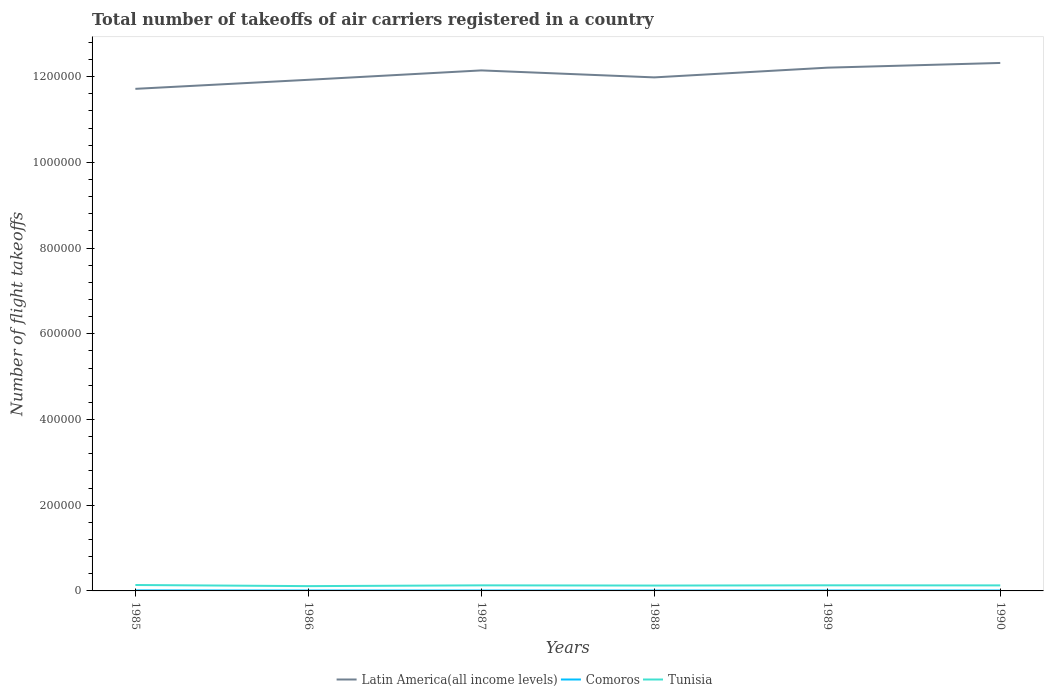How many different coloured lines are there?
Ensure brevity in your answer.  3. Does the line corresponding to Comoros intersect with the line corresponding to Tunisia?
Offer a terse response. No. Across all years, what is the maximum total number of flight takeoffs in Latin America(all income levels)?
Ensure brevity in your answer.  1.17e+06. In which year was the total number of flight takeoffs in Latin America(all income levels) maximum?
Make the answer very short. 1985. What is the difference between the highest and the lowest total number of flight takeoffs in Latin America(all income levels)?
Your answer should be compact. 3. Is the total number of flight takeoffs in Comoros strictly greater than the total number of flight takeoffs in Tunisia over the years?
Provide a succinct answer. Yes. How many lines are there?
Your response must be concise. 3. How many years are there in the graph?
Make the answer very short. 6. What is the difference between two consecutive major ticks on the Y-axis?
Offer a very short reply. 2.00e+05. Are the values on the major ticks of Y-axis written in scientific E-notation?
Give a very brief answer. No. Does the graph contain any zero values?
Offer a very short reply. No. Does the graph contain grids?
Make the answer very short. No. How many legend labels are there?
Your answer should be very brief. 3. How are the legend labels stacked?
Your answer should be very brief. Horizontal. What is the title of the graph?
Your answer should be very brief. Total number of takeoffs of air carriers registered in a country. What is the label or title of the X-axis?
Your response must be concise. Years. What is the label or title of the Y-axis?
Your answer should be compact. Number of flight takeoffs. What is the Number of flight takeoffs in Latin America(all income levels) in 1985?
Your response must be concise. 1.17e+06. What is the Number of flight takeoffs in Comoros in 1985?
Offer a very short reply. 1200. What is the Number of flight takeoffs of Tunisia in 1985?
Make the answer very short. 1.38e+04. What is the Number of flight takeoffs in Latin America(all income levels) in 1986?
Ensure brevity in your answer.  1.19e+06. What is the Number of flight takeoffs in Tunisia in 1986?
Ensure brevity in your answer.  1.12e+04. What is the Number of flight takeoffs of Latin America(all income levels) in 1987?
Give a very brief answer. 1.21e+06. What is the Number of flight takeoffs of Tunisia in 1987?
Make the answer very short. 1.30e+04. What is the Number of flight takeoffs in Latin America(all income levels) in 1988?
Ensure brevity in your answer.  1.20e+06. What is the Number of flight takeoffs in Tunisia in 1988?
Ensure brevity in your answer.  1.25e+04. What is the Number of flight takeoffs of Latin America(all income levels) in 1989?
Give a very brief answer. 1.22e+06. What is the Number of flight takeoffs of Tunisia in 1989?
Provide a short and direct response. 1.31e+04. What is the Number of flight takeoffs in Latin America(all income levels) in 1990?
Provide a short and direct response. 1.23e+06. What is the Number of flight takeoffs in Tunisia in 1990?
Provide a succinct answer. 1.29e+04. Across all years, what is the maximum Number of flight takeoffs in Latin America(all income levels)?
Offer a terse response. 1.23e+06. Across all years, what is the maximum Number of flight takeoffs in Comoros?
Make the answer very short. 1200. Across all years, what is the maximum Number of flight takeoffs of Tunisia?
Offer a terse response. 1.38e+04. Across all years, what is the minimum Number of flight takeoffs in Latin America(all income levels)?
Offer a terse response. 1.17e+06. Across all years, what is the minimum Number of flight takeoffs in Comoros?
Ensure brevity in your answer.  1000. Across all years, what is the minimum Number of flight takeoffs in Tunisia?
Keep it short and to the point. 1.12e+04. What is the total Number of flight takeoffs in Latin America(all income levels) in the graph?
Provide a short and direct response. 7.23e+06. What is the total Number of flight takeoffs in Comoros in the graph?
Provide a short and direct response. 6200. What is the total Number of flight takeoffs of Tunisia in the graph?
Provide a short and direct response. 7.65e+04. What is the difference between the Number of flight takeoffs of Latin America(all income levels) in 1985 and that in 1986?
Keep it short and to the point. -2.11e+04. What is the difference between the Number of flight takeoffs of Comoros in 1985 and that in 1986?
Provide a short and direct response. 200. What is the difference between the Number of flight takeoffs of Tunisia in 1985 and that in 1986?
Your answer should be compact. 2600. What is the difference between the Number of flight takeoffs of Latin America(all income levels) in 1985 and that in 1987?
Ensure brevity in your answer.  -4.30e+04. What is the difference between the Number of flight takeoffs of Tunisia in 1985 and that in 1987?
Your answer should be very brief. 800. What is the difference between the Number of flight takeoffs in Latin America(all income levels) in 1985 and that in 1988?
Your answer should be compact. -2.67e+04. What is the difference between the Number of flight takeoffs of Tunisia in 1985 and that in 1988?
Provide a succinct answer. 1300. What is the difference between the Number of flight takeoffs of Latin America(all income levels) in 1985 and that in 1989?
Provide a short and direct response. -4.94e+04. What is the difference between the Number of flight takeoffs of Comoros in 1985 and that in 1989?
Your response must be concise. 200. What is the difference between the Number of flight takeoffs in Tunisia in 1985 and that in 1989?
Provide a succinct answer. 700. What is the difference between the Number of flight takeoffs of Latin America(all income levels) in 1985 and that in 1990?
Your response must be concise. -6.04e+04. What is the difference between the Number of flight takeoffs in Tunisia in 1985 and that in 1990?
Give a very brief answer. 900. What is the difference between the Number of flight takeoffs in Latin America(all income levels) in 1986 and that in 1987?
Offer a very short reply. -2.19e+04. What is the difference between the Number of flight takeoffs of Comoros in 1986 and that in 1987?
Offer a very short reply. 0. What is the difference between the Number of flight takeoffs in Tunisia in 1986 and that in 1987?
Provide a short and direct response. -1800. What is the difference between the Number of flight takeoffs of Latin America(all income levels) in 1986 and that in 1988?
Ensure brevity in your answer.  -5600. What is the difference between the Number of flight takeoffs of Tunisia in 1986 and that in 1988?
Make the answer very short. -1300. What is the difference between the Number of flight takeoffs in Latin America(all income levels) in 1986 and that in 1989?
Provide a succinct answer. -2.83e+04. What is the difference between the Number of flight takeoffs of Comoros in 1986 and that in 1989?
Keep it short and to the point. 0. What is the difference between the Number of flight takeoffs in Tunisia in 1986 and that in 1989?
Offer a terse response. -1900. What is the difference between the Number of flight takeoffs in Latin America(all income levels) in 1986 and that in 1990?
Provide a short and direct response. -3.93e+04. What is the difference between the Number of flight takeoffs in Tunisia in 1986 and that in 1990?
Give a very brief answer. -1700. What is the difference between the Number of flight takeoffs in Latin America(all income levels) in 1987 and that in 1988?
Provide a short and direct response. 1.63e+04. What is the difference between the Number of flight takeoffs of Comoros in 1987 and that in 1988?
Your response must be concise. 0. What is the difference between the Number of flight takeoffs in Tunisia in 1987 and that in 1988?
Ensure brevity in your answer.  500. What is the difference between the Number of flight takeoffs of Latin America(all income levels) in 1987 and that in 1989?
Your answer should be compact. -6400. What is the difference between the Number of flight takeoffs of Tunisia in 1987 and that in 1989?
Give a very brief answer. -100. What is the difference between the Number of flight takeoffs in Latin America(all income levels) in 1987 and that in 1990?
Provide a short and direct response. -1.74e+04. What is the difference between the Number of flight takeoffs of Comoros in 1987 and that in 1990?
Give a very brief answer. 0. What is the difference between the Number of flight takeoffs in Tunisia in 1987 and that in 1990?
Offer a very short reply. 100. What is the difference between the Number of flight takeoffs of Latin America(all income levels) in 1988 and that in 1989?
Offer a terse response. -2.27e+04. What is the difference between the Number of flight takeoffs of Tunisia in 1988 and that in 1989?
Make the answer very short. -600. What is the difference between the Number of flight takeoffs of Latin America(all income levels) in 1988 and that in 1990?
Your answer should be very brief. -3.37e+04. What is the difference between the Number of flight takeoffs in Tunisia in 1988 and that in 1990?
Offer a terse response. -400. What is the difference between the Number of flight takeoffs in Latin America(all income levels) in 1989 and that in 1990?
Offer a very short reply. -1.10e+04. What is the difference between the Number of flight takeoffs of Comoros in 1989 and that in 1990?
Make the answer very short. 0. What is the difference between the Number of flight takeoffs in Tunisia in 1989 and that in 1990?
Ensure brevity in your answer.  200. What is the difference between the Number of flight takeoffs in Latin America(all income levels) in 1985 and the Number of flight takeoffs in Comoros in 1986?
Provide a succinct answer. 1.17e+06. What is the difference between the Number of flight takeoffs of Latin America(all income levels) in 1985 and the Number of flight takeoffs of Tunisia in 1986?
Keep it short and to the point. 1.16e+06. What is the difference between the Number of flight takeoffs of Latin America(all income levels) in 1985 and the Number of flight takeoffs of Comoros in 1987?
Ensure brevity in your answer.  1.17e+06. What is the difference between the Number of flight takeoffs of Latin America(all income levels) in 1985 and the Number of flight takeoffs of Tunisia in 1987?
Your answer should be very brief. 1.16e+06. What is the difference between the Number of flight takeoffs of Comoros in 1985 and the Number of flight takeoffs of Tunisia in 1987?
Your answer should be very brief. -1.18e+04. What is the difference between the Number of flight takeoffs in Latin America(all income levels) in 1985 and the Number of flight takeoffs in Comoros in 1988?
Your response must be concise. 1.17e+06. What is the difference between the Number of flight takeoffs of Latin America(all income levels) in 1985 and the Number of flight takeoffs of Tunisia in 1988?
Provide a short and direct response. 1.16e+06. What is the difference between the Number of flight takeoffs in Comoros in 1985 and the Number of flight takeoffs in Tunisia in 1988?
Your answer should be compact. -1.13e+04. What is the difference between the Number of flight takeoffs in Latin America(all income levels) in 1985 and the Number of flight takeoffs in Comoros in 1989?
Make the answer very short. 1.17e+06. What is the difference between the Number of flight takeoffs of Latin America(all income levels) in 1985 and the Number of flight takeoffs of Tunisia in 1989?
Provide a succinct answer. 1.16e+06. What is the difference between the Number of flight takeoffs in Comoros in 1985 and the Number of flight takeoffs in Tunisia in 1989?
Offer a terse response. -1.19e+04. What is the difference between the Number of flight takeoffs of Latin America(all income levels) in 1985 and the Number of flight takeoffs of Comoros in 1990?
Your answer should be very brief. 1.17e+06. What is the difference between the Number of flight takeoffs in Latin America(all income levels) in 1985 and the Number of flight takeoffs in Tunisia in 1990?
Your answer should be compact. 1.16e+06. What is the difference between the Number of flight takeoffs in Comoros in 1985 and the Number of flight takeoffs in Tunisia in 1990?
Give a very brief answer. -1.17e+04. What is the difference between the Number of flight takeoffs in Latin America(all income levels) in 1986 and the Number of flight takeoffs in Comoros in 1987?
Your answer should be compact. 1.19e+06. What is the difference between the Number of flight takeoffs in Latin America(all income levels) in 1986 and the Number of flight takeoffs in Tunisia in 1987?
Your response must be concise. 1.18e+06. What is the difference between the Number of flight takeoffs in Comoros in 1986 and the Number of flight takeoffs in Tunisia in 1987?
Offer a very short reply. -1.20e+04. What is the difference between the Number of flight takeoffs of Latin America(all income levels) in 1986 and the Number of flight takeoffs of Comoros in 1988?
Provide a succinct answer. 1.19e+06. What is the difference between the Number of flight takeoffs in Latin America(all income levels) in 1986 and the Number of flight takeoffs in Tunisia in 1988?
Your answer should be very brief. 1.18e+06. What is the difference between the Number of flight takeoffs of Comoros in 1986 and the Number of flight takeoffs of Tunisia in 1988?
Give a very brief answer. -1.15e+04. What is the difference between the Number of flight takeoffs of Latin America(all income levels) in 1986 and the Number of flight takeoffs of Comoros in 1989?
Provide a short and direct response. 1.19e+06. What is the difference between the Number of flight takeoffs of Latin America(all income levels) in 1986 and the Number of flight takeoffs of Tunisia in 1989?
Offer a very short reply. 1.18e+06. What is the difference between the Number of flight takeoffs of Comoros in 1986 and the Number of flight takeoffs of Tunisia in 1989?
Keep it short and to the point. -1.21e+04. What is the difference between the Number of flight takeoffs of Latin America(all income levels) in 1986 and the Number of flight takeoffs of Comoros in 1990?
Give a very brief answer. 1.19e+06. What is the difference between the Number of flight takeoffs in Latin America(all income levels) in 1986 and the Number of flight takeoffs in Tunisia in 1990?
Offer a very short reply. 1.18e+06. What is the difference between the Number of flight takeoffs of Comoros in 1986 and the Number of flight takeoffs of Tunisia in 1990?
Your response must be concise. -1.19e+04. What is the difference between the Number of flight takeoffs in Latin America(all income levels) in 1987 and the Number of flight takeoffs in Comoros in 1988?
Offer a terse response. 1.21e+06. What is the difference between the Number of flight takeoffs in Latin America(all income levels) in 1987 and the Number of flight takeoffs in Tunisia in 1988?
Keep it short and to the point. 1.20e+06. What is the difference between the Number of flight takeoffs in Comoros in 1987 and the Number of flight takeoffs in Tunisia in 1988?
Keep it short and to the point. -1.15e+04. What is the difference between the Number of flight takeoffs of Latin America(all income levels) in 1987 and the Number of flight takeoffs of Comoros in 1989?
Provide a succinct answer. 1.21e+06. What is the difference between the Number of flight takeoffs in Latin America(all income levels) in 1987 and the Number of flight takeoffs in Tunisia in 1989?
Provide a succinct answer. 1.20e+06. What is the difference between the Number of flight takeoffs in Comoros in 1987 and the Number of flight takeoffs in Tunisia in 1989?
Offer a terse response. -1.21e+04. What is the difference between the Number of flight takeoffs in Latin America(all income levels) in 1987 and the Number of flight takeoffs in Comoros in 1990?
Your response must be concise. 1.21e+06. What is the difference between the Number of flight takeoffs of Latin America(all income levels) in 1987 and the Number of flight takeoffs of Tunisia in 1990?
Your answer should be compact. 1.20e+06. What is the difference between the Number of flight takeoffs of Comoros in 1987 and the Number of flight takeoffs of Tunisia in 1990?
Your answer should be compact. -1.19e+04. What is the difference between the Number of flight takeoffs in Latin America(all income levels) in 1988 and the Number of flight takeoffs in Comoros in 1989?
Offer a terse response. 1.20e+06. What is the difference between the Number of flight takeoffs in Latin America(all income levels) in 1988 and the Number of flight takeoffs in Tunisia in 1989?
Offer a terse response. 1.19e+06. What is the difference between the Number of flight takeoffs in Comoros in 1988 and the Number of flight takeoffs in Tunisia in 1989?
Offer a very short reply. -1.21e+04. What is the difference between the Number of flight takeoffs of Latin America(all income levels) in 1988 and the Number of flight takeoffs of Comoros in 1990?
Your response must be concise. 1.20e+06. What is the difference between the Number of flight takeoffs in Latin America(all income levels) in 1988 and the Number of flight takeoffs in Tunisia in 1990?
Your response must be concise. 1.19e+06. What is the difference between the Number of flight takeoffs in Comoros in 1988 and the Number of flight takeoffs in Tunisia in 1990?
Your answer should be compact. -1.19e+04. What is the difference between the Number of flight takeoffs in Latin America(all income levels) in 1989 and the Number of flight takeoffs in Comoros in 1990?
Make the answer very short. 1.22e+06. What is the difference between the Number of flight takeoffs in Latin America(all income levels) in 1989 and the Number of flight takeoffs in Tunisia in 1990?
Offer a terse response. 1.21e+06. What is the difference between the Number of flight takeoffs of Comoros in 1989 and the Number of flight takeoffs of Tunisia in 1990?
Offer a terse response. -1.19e+04. What is the average Number of flight takeoffs of Latin America(all income levels) per year?
Your response must be concise. 1.20e+06. What is the average Number of flight takeoffs in Comoros per year?
Your answer should be compact. 1033.33. What is the average Number of flight takeoffs in Tunisia per year?
Offer a terse response. 1.28e+04. In the year 1985, what is the difference between the Number of flight takeoffs of Latin America(all income levels) and Number of flight takeoffs of Comoros?
Make the answer very short. 1.17e+06. In the year 1985, what is the difference between the Number of flight takeoffs in Latin America(all income levels) and Number of flight takeoffs in Tunisia?
Provide a short and direct response. 1.16e+06. In the year 1985, what is the difference between the Number of flight takeoffs of Comoros and Number of flight takeoffs of Tunisia?
Keep it short and to the point. -1.26e+04. In the year 1986, what is the difference between the Number of flight takeoffs of Latin America(all income levels) and Number of flight takeoffs of Comoros?
Provide a succinct answer. 1.19e+06. In the year 1986, what is the difference between the Number of flight takeoffs in Latin America(all income levels) and Number of flight takeoffs in Tunisia?
Provide a short and direct response. 1.18e+06. In the year 1986, what is the difference between the Number of flight takeoffs in Comoros and Number of flight takeoffs in Tunisia?
Make the answer very short. -1.02e+04. In the year 1987, what is the difference between the Number of flight takeoffs in Latin America(all income levels) and Number of flight takeoffs in Comoros?
Offer a terse response. 1.21e+06. In the year 1987, what is the difference between the Number of flight takeoffs in Latin America(all income levels) and Number of flight takeoffs in Tunisia?
Provide a short and direct response. 1.20e+06. In the year 1987, what is the difference between the Number of flight takeoffs in Comoros and Number of flight takeoffs in Tunisia?
Offer a very short reply. -1.20e+04. In the year 1988, what is the difference between the Number of flight takeoffs of Latin America(all income levels) and Number of flight takeoffs of Comoros?
Provide a succinct answer. 1.20e+06. In the year 1988, what is the difference between the Number of flight takeoffs in Latin America(all income levels) and Number of flight takeoffs in Tunisia?
Offer a very short reply. 1.19e+06. In the year 1988, what is the difference between the Number of flight takeoffs of Comoros and Number of flight takeoffs of Tunisia?
Your answer should be compact. -1.15e+04. In the year 1989, what is the difference between the Number of flight takeoffs of Latin America(all income levels) and Number of flight takeoffs of Comoros?
Ensure brevity in your answer.  1.22e+06. In the year 1989, what is the difference between the Number of flight takeoffs of Latin America(all income levels) and Number of flight takeoffs of Tunisia?
Keep it short and to the point. 1.21e+06. In the year 1989, what is the difference between the Number of flight takeoffs of Comoros and Number of flight takeoffs of Tunisia?
Make the answer very short. -1.21e+04. In the year 1990, what is the difference between the Number of flight takeoffs in Latin America(all income levels) and Number of flight takeoffs in Comoros?
Your answer should be very brief. 1.23e+06. In the year 1990, what is the difference between the Number of flight takeoffs in Latin America(all income levels) and Number of flight takeoffs in Tunisia?
Keep it short and to the point. 1.22e+06. In the year 1990, what is the difference between the Number of flight takeoffs of Comoros and Number of flight takeoffs of Tunisia?
Offer a terse response. -1.19e+04. What is the ratio of the Number of flight takeoffs in Latin America(all income levels) in 1985 to that in 1986?
Ensure brevity in your answer.  0.98. What is the ratio of the Number of flight takeoffs of Comoros in 1985 to that in 1986?
Ensure brevity in your answer.  1.2. What is the ratio of the Number of flight takeoffs of Tunisia in 1985 to that in 1986?
Offer a terse response. 1.23. What is the ratio of the Number of flight takeoffs in Latin America(all income levels) in 1985 to that in 1987?
Your answer should be compact. 0.96. What is the ratio of the Number of flight takeoffs in Tunisia in 1985 to that in 1987?
Your response must be concise. 1.06. What is the ratio of the Number of flight takeoffs of Latin America(all income levels) in 1985 to that in 1988?
Provide a short and direct response. 0.98. What is the ratio of the Number of flight takeoffs of Comoros in 1985 to that in 1988?
Your response must be concise. 1.2. What is the ratio of the Number of flight takeoffs of Tunisia in 1985 to that in 1988?
Offer a terse response. 1.1. What is the ratio of the Number of flight takeoffs of Latin America(all income levels) in 1985 to that in 1989?
Provide a short and direct response. 0.96. What is the ratio of the Number of flight takeoffs in Tunisia in 1985 to that in 1989?
Offer a very short reply. 1.05. What is the ratio of the Number of flight takeoffs in Latin America(all income levels) in 1985 to that in 1990?
Offer a very short reply. 0.95. What is the ratio of the Number of flight takeoffs in Tunisia in 1985 to that in 1990?
Provide a succinct answer. 1.07. What is the ratio of the Number of flight takeoffs of Latin America(all income levels) in 1986 to that in 1987?
Give a very brief answer. 0.98. What is the ratio of the Number of flight takeoffs of Tunisia in 1986 to that in 1987?
Your answer should be compact. 0.86. What is the ratio of the Number of flight takeoffs of Latin America(all income levels) in 1986 to that in 1988?
Give a very brief answer. 1. What is the ratio of the Number of flight takeoffs of Tunisia in 1986 to that in 1988?
Make the answer very short. 0.9. What is the ratio of the Number of flight takeoffs of Latin America(all income levels) in 1986 to that in 1989?
Ensure brevity in your answer.  0.98. What is the ratio of the Number of flight takeoffs in Comoros in 1986 to that in 1989?
Make the answer very short. 1. What is the ratio of the Number of flight takeoffs in Tunisia in 1986 to that in 1989?
Offer a very short reply. 0.85. What is the ratio of the Number of flight takeoffs in Latin America(all income levels) in 1986 to that in 1990?
Keep it short and to the point. 0.97. What is the ratio of the Number of flight takeoffs in Tunisia in 1986 to that in 1990?
Offer a terse response. 0.87. What is the ratio of the Number of flight takeoffs in Latin America(all income levels) in 1987 to that in 1988?
Offer a terse response. 1.01. What is the ratio of the Number of flight takeoffs in Comoros in 1987 to that in 1988?
Give a very brief answer. 1. What is the ratio of the Number of flight takeoffs of Comoros in 1987 to that in 1989?
Keep it short and to the point. 1. What is the ratio of the Number of flight takeoffs in Tunisia in 1987 to that in 1989?
Your answer should be very brief. 0.99. What is the ratio of the Number of flight takeoffs of Latin America(all income levels) in 1987 to that in 1990?
Offer a very short reply. 0.99. What is the ratio of the Number of flight takeoffs in Comoros in 1987 to that in 1990?
Make the answer very short. 1. What is the ratio of the Number of flight takeoffs in Latin America(all income levels) in 1988 to that in 1989?
Offer a terse response. 0.98. What is the ratio of the Number of flight takeoffs of Comoros in 1988 to that in 1989?
Your answer should be compact. 1. What is the ratio of the Number of flight takeoffs in Tunisia in 1988 to that in 1989?
Your response must be concise. 0.95. What is the ratio of the Number of flight takeoffs of Latin America(all income levels) in 1988 to that in 1990?
Offer a terse response. 0.97. What is the ratio of the Number of flight takeoffs in Tunisia in 1988 to that in 1990?
Make the answer very short. 0.97. What is the ratio of the Number of flight takeoffs of Latin America(all income levels) in 1989 to that in 1990?
Keep it short and to the point. 0.99. What is the ratio of the Number of flight takeoffs in Comoros in 1989 to that in 1990?
Your response must be concise. 1. What is the ratio of the Number of flight takeoffs in Tunisia in 1989 to that in 1990?
Give a very brief answer. 1.02. What is the difference between the highest and the second highest Number of flight takeoffs of Latin America(all income levels)?
Your answer should be compact. 1.10e+04. What is the difference between the highest and the second highest Number of flight takeoffs in Comoros?
Offer a very short reply. 200. What is the difference between the highest and the second highest Number of flight takeoffs in Tunisia?
Make the answer very short. 700. What is the difference between the highest and the lowest Number of flight takeoffs in Latin America(all income levels)?
Your response must be concise. 6.04e+04. What is the difference between the highest and the lowest Number of flight takeoffs of Comoros?
Offer a terse response. 200. What is the difference between the highest and the lowest Number of flight takeoffs in Tunisia?
Your answer should be compact. 2600. 